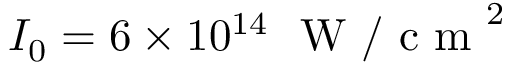<formula> <loc_0><loc_0><loc_500><loc_500>I _ { 0 } = 6 \times 1 0 ^ { 1 4 } W / c m ^ { 2 }</formula> 